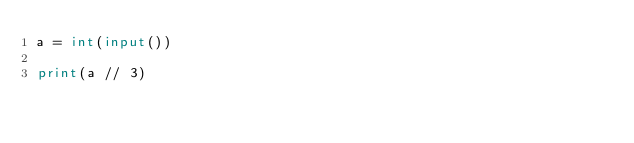Convert code to text. <code><loc_0><loc_0><loc_500><loc_500><_Python_>a = int(input())

print(a // 3)</code> 